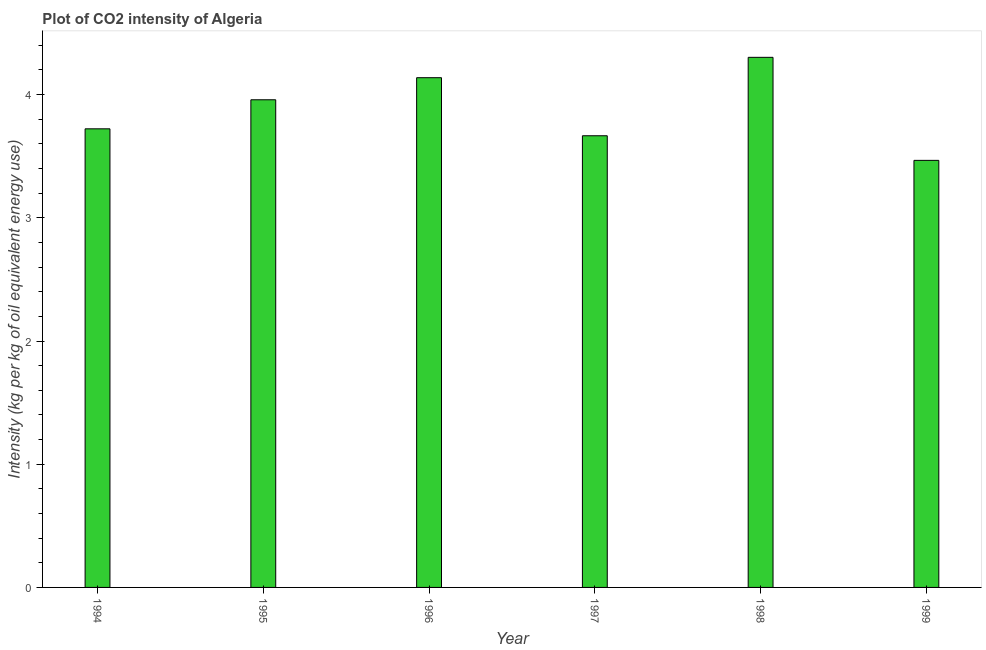Does the graph contain any zero values?
Offer a terse response. No. Does the graph contain grids?
Keep it short and to the point. No. What is the title of the graph?
Your answer should be very brief. Plot of CO2 intensity of Algeria. What is the label or title of the X-axis?
Give a very brief answer. Year. What is the label or title of the Y-axis?
Offer a terse response. Intensity (kg per kg of oil equivalent energy use). What is the co2 intensity in 1995?
Offer a terse response. 3.96. Across all years, what is the maximum co2 intensity?
Offer a very short reply. 4.3. Across all years, what is the minimum co2 intensity?
Make the answer very short. 3.47. In which year was the co2 intensity maximum?
Give a very brief answer. 1998. What is the sum of the co2 intensity?
Your answer should be very brief. 23.25. What is the difference between the co2 intensity in 1994 and 1996?
Your response must be concise. -0.41. What is the average co2 intensity per year?
Your answer should be very brief. 3.88. What is the median co2 intensity?
Your answer should be very brief. 3.84. What is the ratio of the co2 intensity in 1995 to that in 1999?
Ensure brevity in your answer.  1.14. Is the difference between the co2 intensity in 1996 and 1997 greater than the difference between any two years?
Your answer should be compact. No. What is the difference between the highest and the second highest co2 intensity?
Make the answer very short. 0.17. What is the difference between the highest and the lowest co2 intensity?
Your answer should be compact. 0.84. How many years are there in the graph?
Provide a short and direct response. 6. What is the difference between two consecutive major ticks on the Y-axis?
Make the answer very short. 1. What is the Intensity (kg per kg of oil equivalent energy use) of 1994?
Your answer should be compact. 3.72. What is the Intensity (kg per kg of oil equivalent energy use) of 1995?
Keep it short and to the point. 3.96. What is the Intensity (kg per kg of oil equivalent energy use) in 1996?
Provide a succinct answer. 4.14. What is the Intensity (kg per kg of oil equivalent energy use) of 1997?
Offer a terse response. 3.67. What is the Intensity (kg per kg of oil equivalent energy use) of 1998?
Your answer should be very brief. 4.3. What is the Intensity (kg per kg of oil equivalent energy use) in 1999?
Your response must be concise. 3.47. What is the difference between the Intensity (kg per kg of oil equivalent energy use) in 1994 and 1995?
Make the answer very short. -0.24. What is the difference between the Intensity (kg per kg of oil equivalent energy use) in 1994 and 1996?
Give a very brief answer. -0.41. What is the difference between the Intensity (kg per kg of oil equivalent energy use) in 1994 and 1997?
Your response must be concise. 0.06. What is the difference between the Intensity (kg per kg of oil equivalent energy use) in 1994 and 1998?
Offer a terse response. -0.58. What is the difference between the Intensity (kg per kg of oil equivalent energy use) in 1994 and 1999?
Your answer should be very brief. 0.26. What is the difference between the Intensity (kg per kg of oil equivalent energy use) in 1995 and 1996?
Make the answer very short. -0.18. What is the difference between the Intensity (kg per kg of oil equivalent energy use) in 1995 and 1997?
Provide a short and direct response. 0.29. What is the difference between the Intensity (kg per kg of oil equivalent energy use) in 1995 and 1998?
Make the answer very short. -0.34. What is the difference between the Intensity (kg per kg of oil equivalent energy use) in 1995 and 1999?
Your response must be concise. 0.49. What is the difference between the Intensity (kg per kg of oil equivalent energy use) in 1996 and 1997?
Your answer should be compact. 0.47. What is the difference between the Intensity (kg per kg of oil equivalent energy use) in 1996 and 1998?
Give a very brief answer. -0.17. What is the difference between the Intensity (kg per kg of oil equivalent energy use) in 1996 and 1999?
Offer a very short reply. 0.67. What is the difference between the Intensity (kg per kg of oil equivalent energy use) in 1997 and 1998?
Make the answer very short. -0.64. What is the difference between the Intensity (kg per kg of oil equivalent energy use) in 1997 and 1999?
Keep it short and to the point. 0.2. What is the difference between the Intensity (kg per kg of oil equivalent energy use) in 1998 and 1999?
Your answer should be compact. 0.84. What is the ratio of the Intensity (kg per kg of oil equivalent energy use) in 1994 to that in 1998?
Offer a terse response. 0.86. What is the ratio of the Intensity (kg per kg of oil equivalent energy use) in 1994 to that in 1999?
Your response must be concise. 1.07. What is the ratio of the Intensity (kg per kg of oil equivalent energy use) in 1995 to that in 1996?
Provide a short and direct response. 0.96. What is the ratio of the Intensity (kg per kg of oil equivalent energy use) in 1995 to that in 1997?
Your response must be concise. 1.08. What is the ratio of the Intensity (kg per kg of oil equivalent energy use) in 1995 to that in 1999?
Offer a terse response. 1.14. What is the ratio of the Intensity (kg per kg of oil equivalent energy use) in 1996 to that in 1997?
Your answer should be compact. 1.13. What is the ratio of the Intensity (kg per kg of oil equivalent energy use) in 1996 to that in 1999?
Provide a succinct answer. 1.19. What is the ratio of the Intensity (kg per kg of oil equivalent energy use) in 1997 to that in 1998?
Provide a short and direct response. 0.85. What is the ratio of the Intensity (kg per kg of oil equivalent energy use) in 1997 to that in 1999?
Your answer should be compact. 1.06. What is the ratio of the Intensity (kg per kg of oil equivalent energy use) in 1998 to that in 1999?
Make the answer very short. 1.24. 